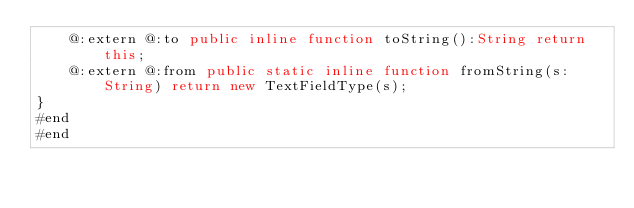Convert code to text. <code><loc_0><loc_0><loc_500><loc_500><_Haxe_>	@:extern @:to public inline function toString():String return this;
	@:extern @:from public static inline function fromString(s:String) return new TextFieldType(s);
}
#end
#end
</code> 